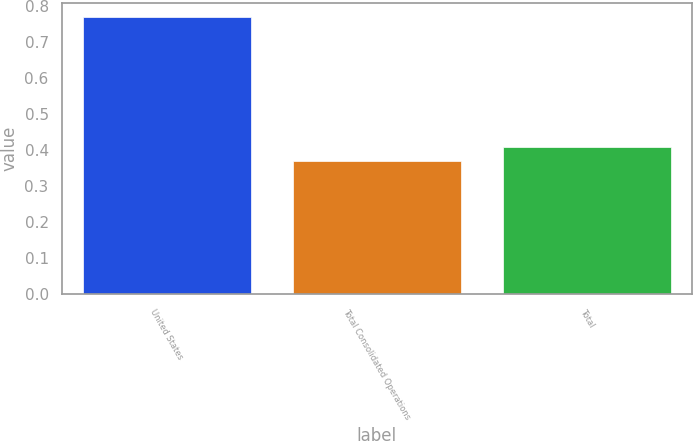<chart> <loc_0><loc_0><loc_500><loc_500><bar_chart><fcel>United States<fcel>Total Consolidated Operations<fcel>Total<nl><fcel>0.77<fcel>0.37<fcel>0.41<nl></chart> 